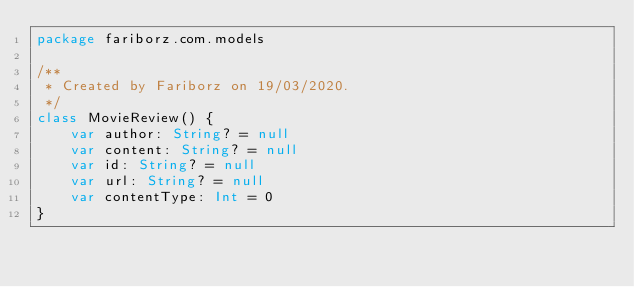Convert code to text. <code><loc_0><loc_0><loc_500><loc_500><_Kotlin_>package fariborz.com.models

/**
 * Created by Fariborz on 19/03/2020.
 */
class MovieReview() {
    var author: String? = null
    var content: String? = null
    var id: String? = null
    var url: String? = null
    var contentType: Int = 0
}</code> 